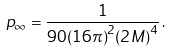<formula> <loc_0><loc_0><loc_500><loc_500>p _ { \infty } = \frac { 1 } { 9 0 { ( 1 6 \pi ) } ^ { 2 } { ( 2 M ) } ^ { 4 } } \, .</formula> 